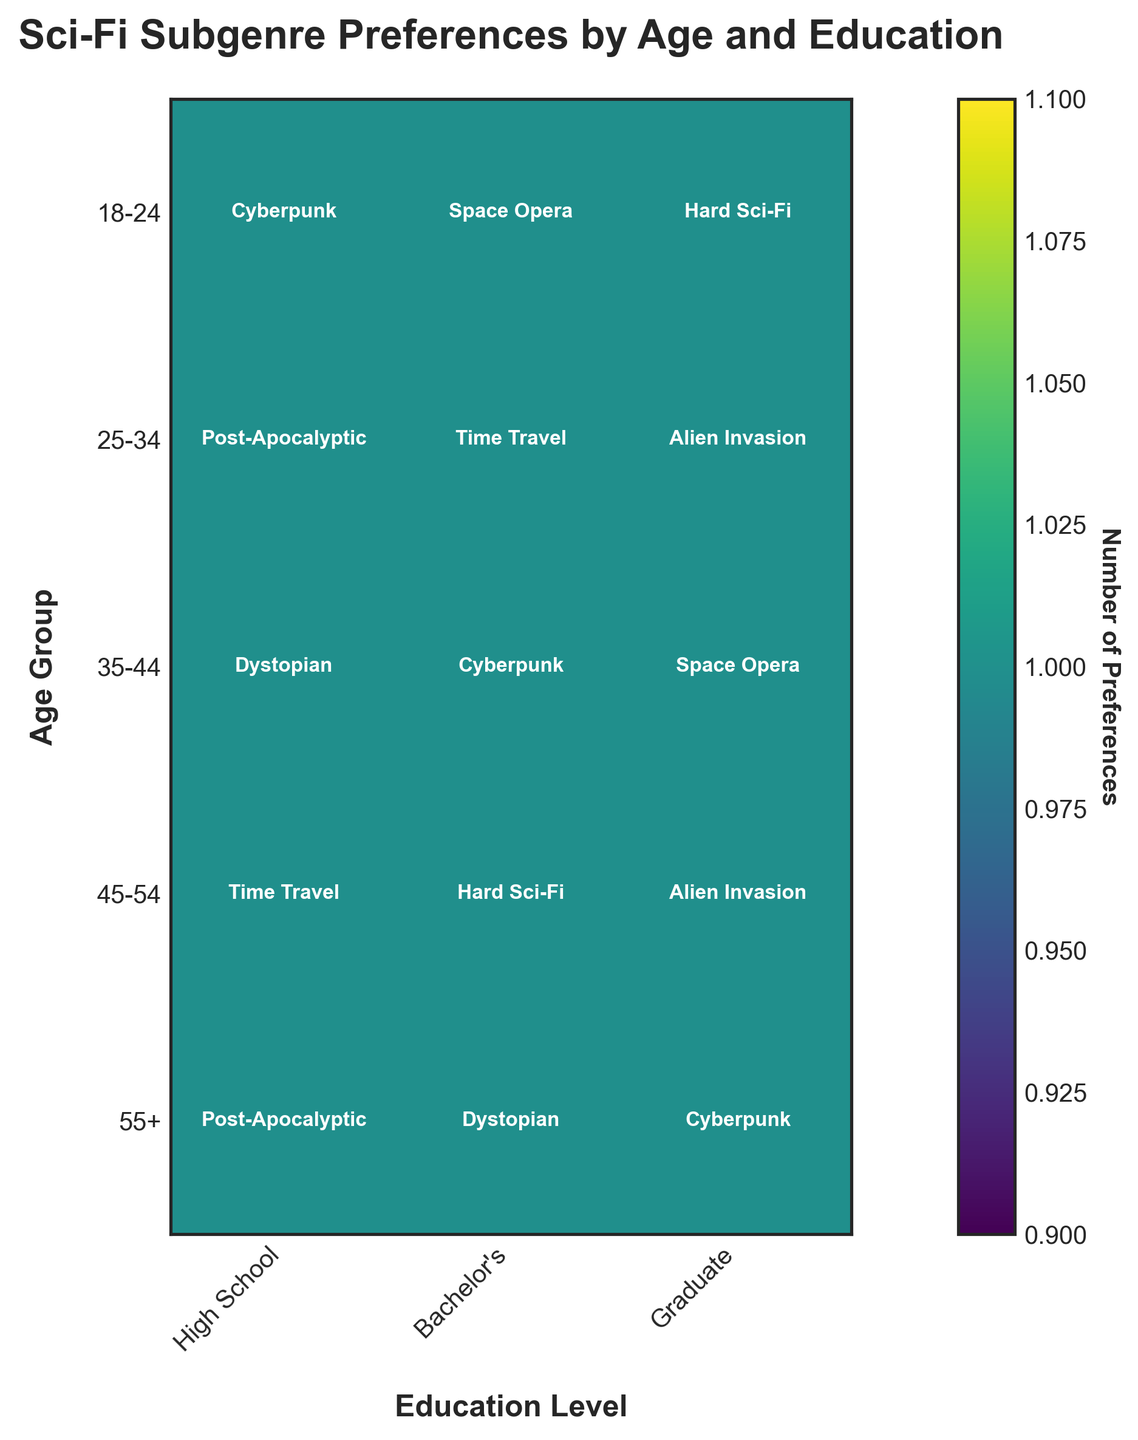What's the title of the plot? The title is displayed at the top of the plot, it summarizes what the data visualization is about. The title is "Sci-Fi Subgenre Preferences by Age and Education".
Answer: Sci-Fi Subgenre Preferences by Age and Education What does the colorbar represent? The colorbar on the side of the plot indicates the quantity of preferences. Its label reads "Number of Preferences", which means it shows the count of data points within each category combination.
Answer: Number of Preferences What preferred sci-fi subgenre is most common among 18-24-year-olds with a Bachelor's degree? Locate the cell in the plot corresponding to the 18-24 age group and Bachelor's education level, and read the text within this cell. The subgenre is "Space Opera".
Answer: Space Opera Which age group shows a preference for the "Alien Invasion" subgenre at a graduate education level? Find the cells labeled with "Graduate" along the x-axis and look for the "Alien Invasion" subgenre in these cells. This subgenre is seen in the age groups 25-34 and 45-54.
Answer: 25-34 and 45-54 How many age and education group combinations prefer "Cyberpunk"? Scan across all cells in the plot to identify how many of them are labeled with the "Cyberpunk" subgenre. There are three: 18-24 with High School, 35-44 with Bachelor's, and 55+ with Graduate.
Answer: 3 Which education level among the 35-44 age group shows a preference for "Space Opera"? Look at the row corresponding to the 35-44 age group and identify which cell has "Space Opera" among the education levels. This matches with Graduate education level.
Answer: Graduate Compare the number of preferences for "Post-Apocalyptic" between High School education levels in the 25-34 and 55+ age groups. Which age group has more? Compare the cells for "Post-Apocalyptic" in the 25-34 and 55+ rows under High School education level. Both cells are labeled, indicating equal amounts.
Answer: Same amount Which subgenre is preferred by the least number of groups? Count the occurrences of each subgenre in the plot. The one appearing in the fewest number of cells is "Dystopian", which is seen in only two groups: 35-44 with High School and 55+ with Bachelor's.
Answer: Dystopian For the age group 45-54, rank the preferred subgenres by education level from High School to Graduate. Review the cells in the row for 45-54 age group and list the subgenres in order of education level: High School = Time Travel, Bachelor's = Hard Sci-Fi, Graduate = Alien Invasion.
Answer: Time Travel, Hard Sci-Fi, Alien Invasion 